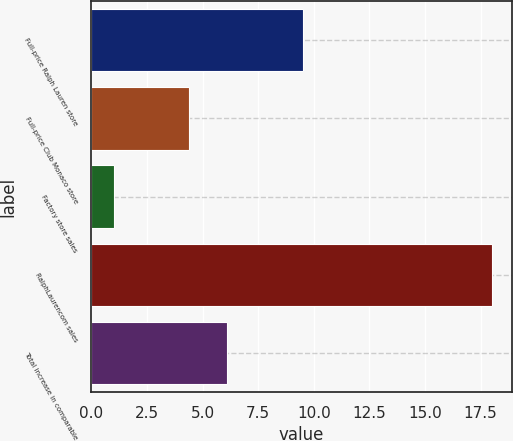Convert chart to OTSL. <chart><loc_0><loc_0><loc_500><loc_500><bar_chart><fcel>Full-price Ralph Lauren store<fcel>Full-price Club Monaco store<fcel>Factory store sales<fcel>RalphLaurencom sales<fcel>Total increase in comparable<nl><fcel>9.5<fcel>4.4<fcel>1<fcel>18<fcel>6.1<nl></chart> 